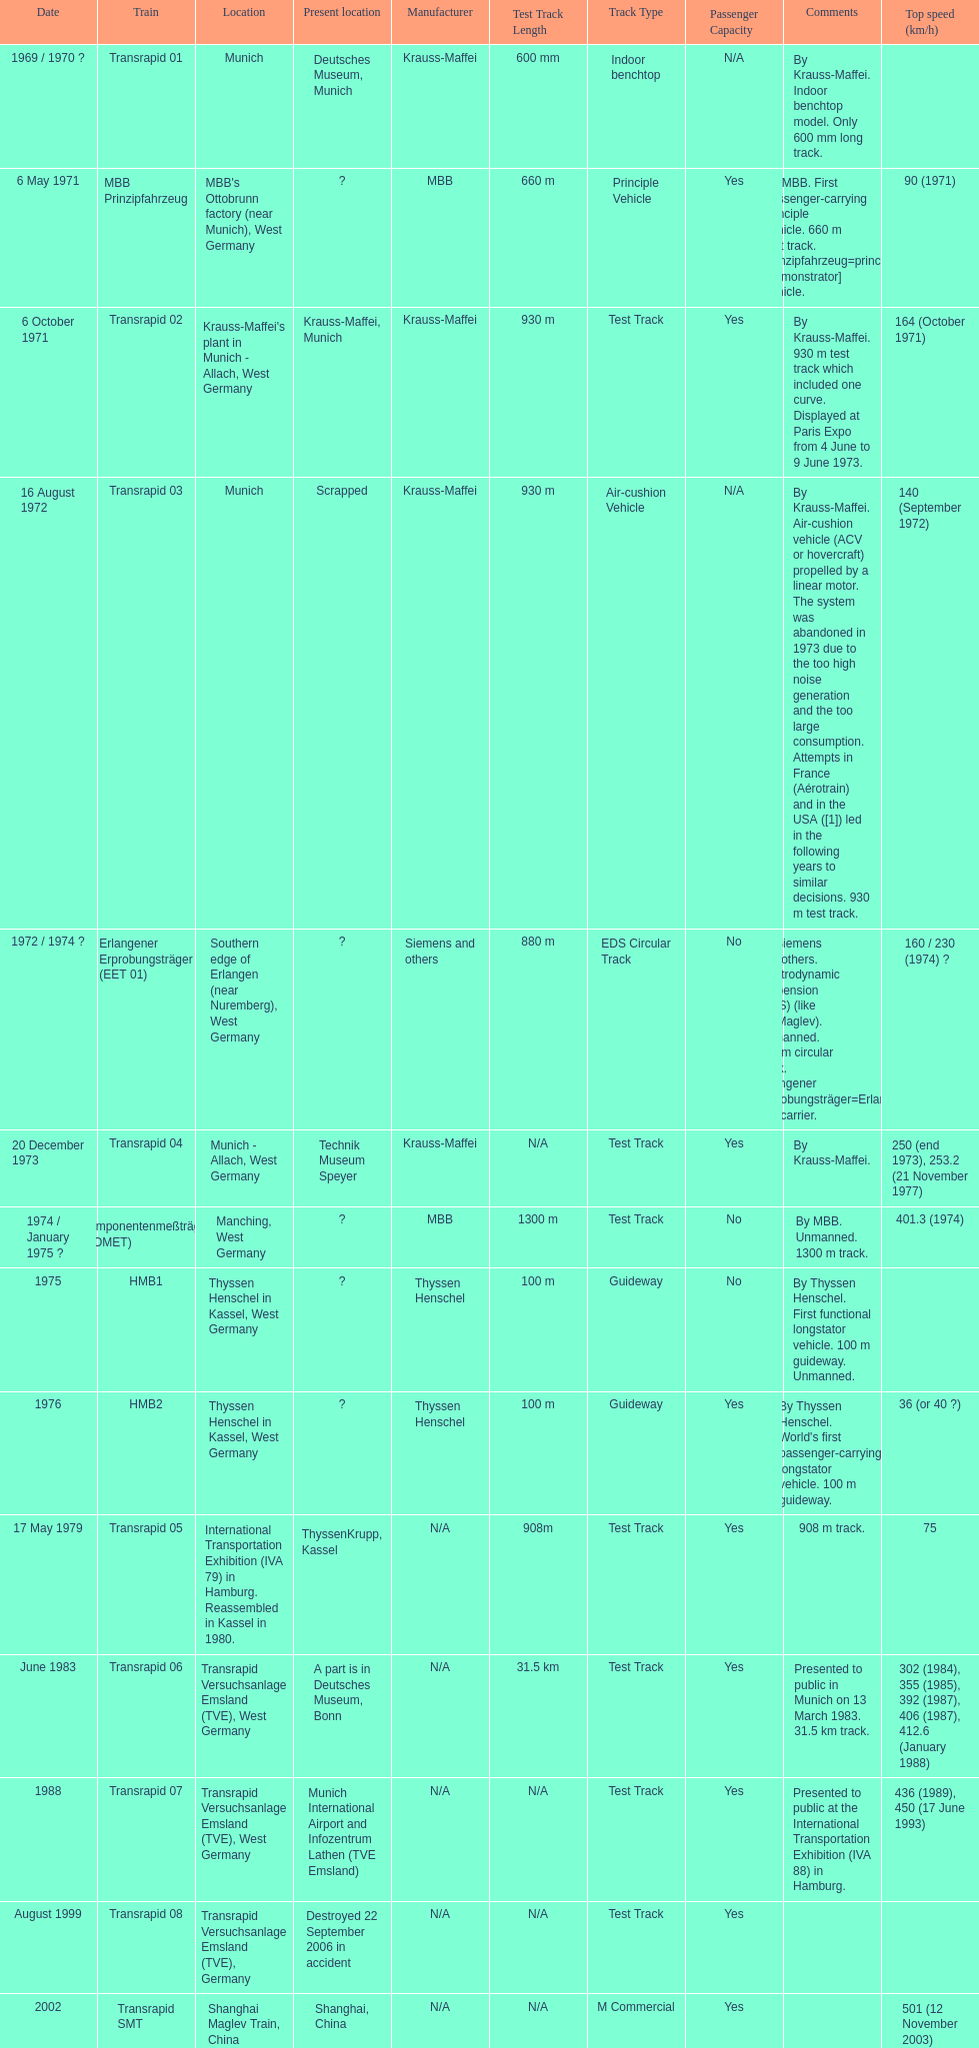What is the only train to reach a top speed of 500 or more? Transrapid SMT. 